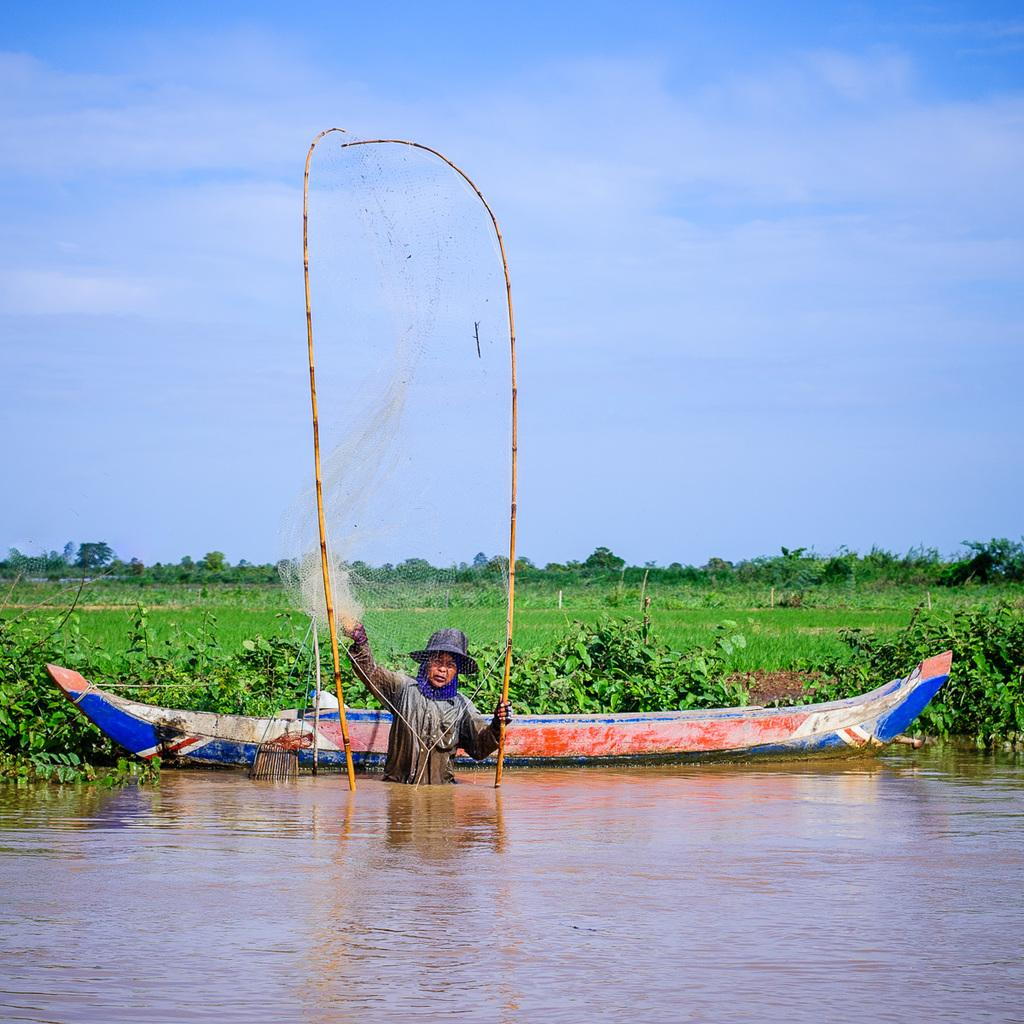What is the person in the image doing? The person is standing in the water and holding a net. What can be seen in the background of the image? There is a boat, grass, and trees visible in the background. What might the person be trying to catch with the net? It is not clear what the person is trying to catch, but they are holding a net, which is often used for catching fish or other aquatic creatures. What type of bed can be seen in the image? There is no bed present in the image; it features a person standing in water holding a net. 